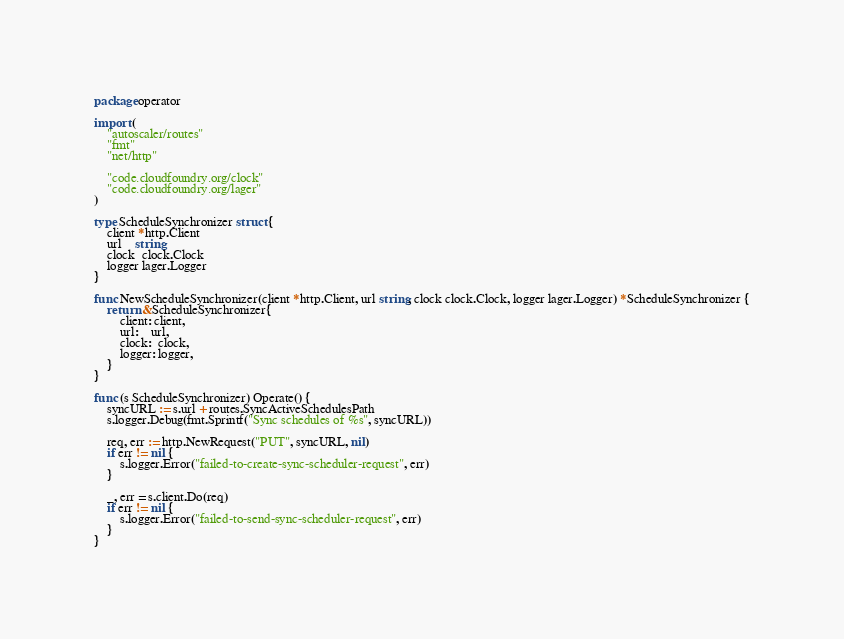Convert code to text. <code><loc_0><loc_0><loc_500><loc_500><_Go_>package operator

import (
	"autoscaler/routes"
	"fmt"
	"net/http"

	"code.cloudfoundry.org/clock"
	"code.cloudfoundry.org/lager"
)

type ScheduleSynchronizer struct {
	client *http.Client
	url    string
	clock  clock.Clock
	logger lager.Logger
}

func NewScheduleSynchronizer(client *http.Client, url string, clock clock.Clock, logger lager.Logger) *ScheduleSynchronizer {
	return &ScheduleSynchronizer{
		client: client,
		url:    url,
		clock:  clock,
		logger: logger,
	}
}

func (s ScheduleSynchronizer) Operate() {
	syncURL := s.url + routes.SyncActiveSchedulesPath
	s.logger.Debug(fmt.Sprintf("Sync schedules of %s", syncURL))

	req, err := http.NewRequest("PUT", syncURL, nil)
	if err != nil {
		s.logger.Error("failed-to-create-sync-scheduler-request", err)
	}

	_, err = s.client.Do(req)
	if err != nil {
		s.logger.Error("failed-to-send-sync-scheduler-request", err)
	}
}
</code> 